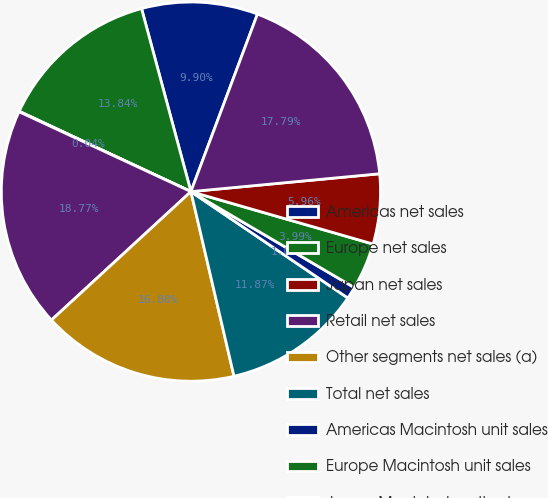Convert chart to OTSL. <chart><loc_0><loc_0><loc_500><loc_500><pie_chart><fcel>Americas net sales<fcel>Europe net sales<fcel>Japan net sales<fcel>Retail net sales<fcel>Other segments net sales (a)<fcel>Total net sales<fcel>Americas Macintosh unit sales<fcel>Europe Macintosh unit sales<fcel>Japan Macintosh unit sales<fcel>Retail Macintosh unit sales<nl><fcel>9.9%<fcel>13.84%<fcel>0.04%<fcel>18.77%<fcel>16.8%<fcel>11.87%<fcel>1.03%<fcel>3.99%<fcel>5.96%<fcel>17.79%<nl></chart> 